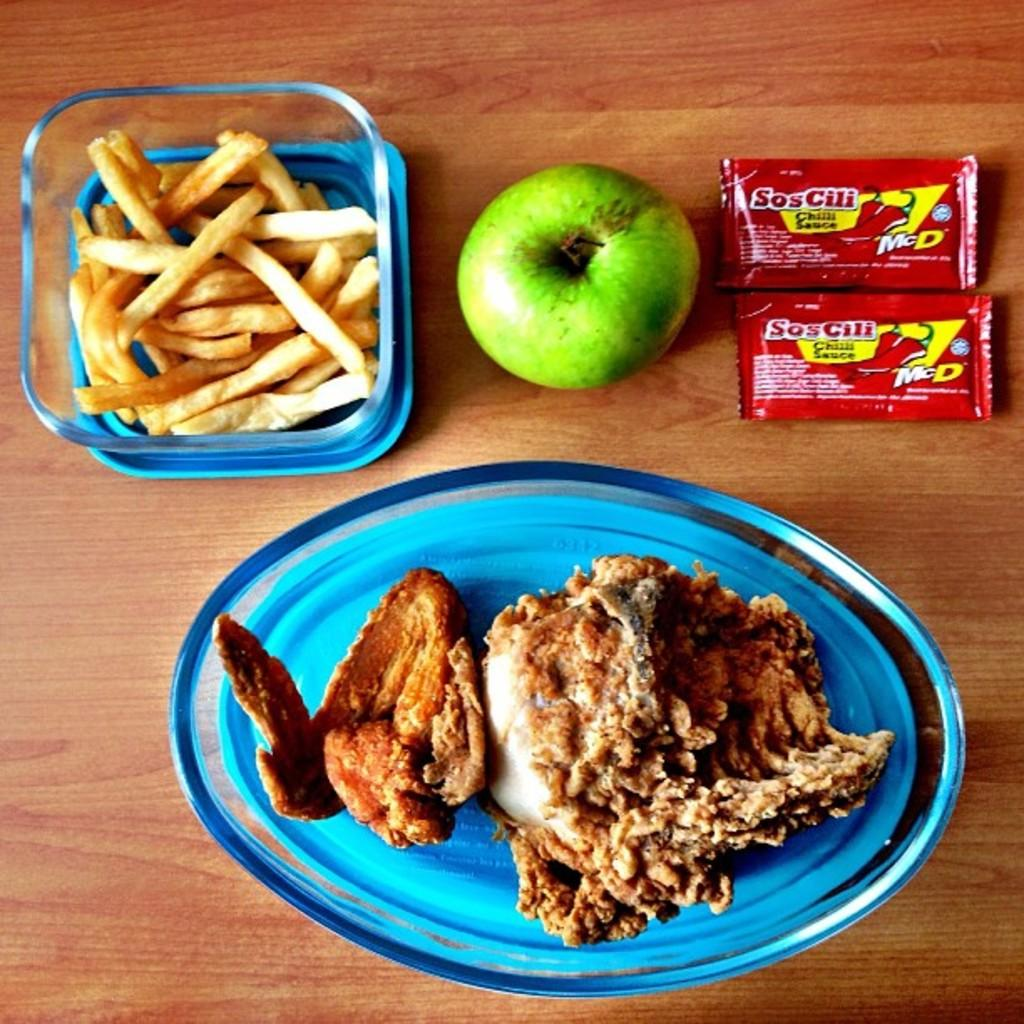What type of fruit is in the image? There is a green apple in the image. What type of condiments are in the image? There are sauce packets in the image. What type of food is in the image? There is a bowl of french fries and a plate of food in the image. What type of surface is visible in the background of the image? The wooden surface is visible in the background of the image. Can you see any sugar on the seashore in the image? There is no seashore or sugar present in the image. 